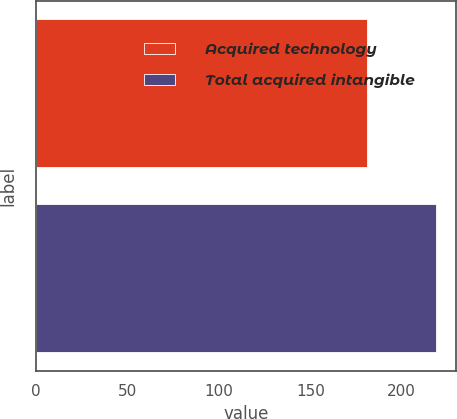Convert chart to OTSL. <chart><loc_0><loc_0><loc_500><loc_500><bar_chart><fcel>Acquired technology<fcel>Total acquired intangible<nl><fcel>181<fcel>219<nl></chart> 